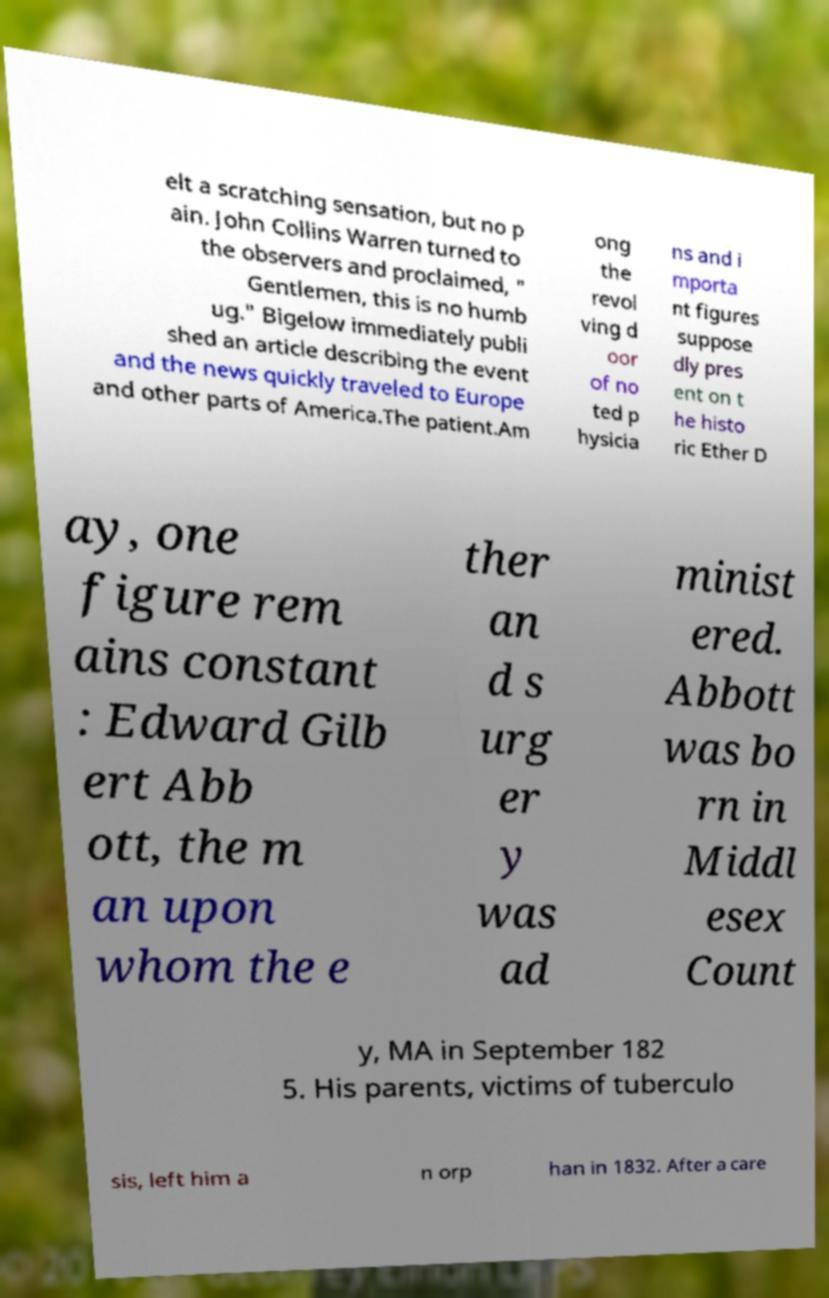For documentation purposes, I need the text within this image transcribed. Could you provide that? elt a scratching sensation, but no p ain. John Collins Warren turned to the observers and proclaimed, " Gentlemen, this is no humb ug." Bigelow immediately publi shed an article describing the event and the news quickly traveled to Europe and other parts of America.The patient.Am ong the revol ving d oor of no ted p hysicia ns and i mporta nt figures suppose dly pres ent on t he histo ric Ether D ay, one figure rem ains constant : Edward Gilb ert Abb ott, the m an upon whom the e ther an d s urg er y was ad minist ered. Abbott was bo rn in Middl esex Count y, MA in September 182 5. His parents, victims of tuberculo sis, left him a n orp han in 1832. After a care 